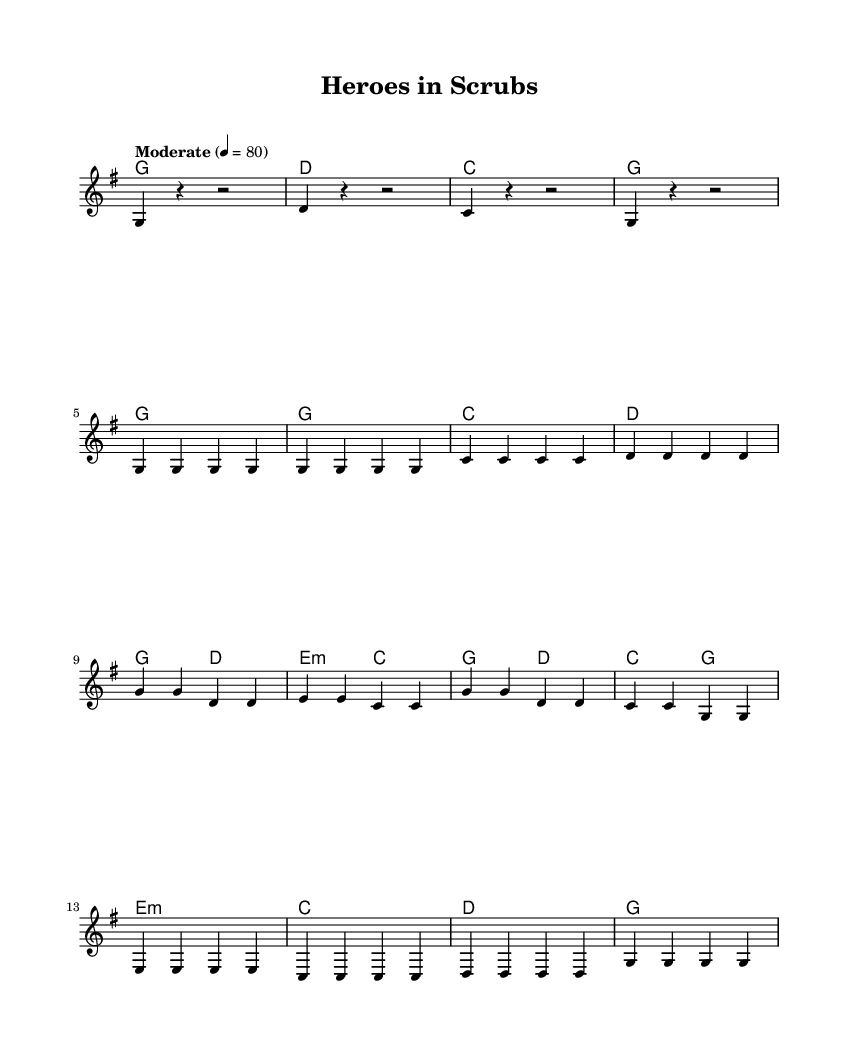What is the key signature of this music? The key signature is G major, which has one sharp (F#). This can be determined by looking at the key signature noted at the beginning of the score, which is indicated by the 'g' key specified.
Answer: G major What is the time signature of this music? The time signature is 4/4, which indicates four beats per measure and a quarter note gets one beat. This information is usually found at the beginning of the piece, immediately following the key signature.
Answer: 4/4 What is the tempo marking for this music? The tempo marking is "Moderate" with a speed of 80 beats per minute. This tells performers how fast or slow to play the piece, as shown in the tempo indication section of the score.
Answer: Moderate How many measures are in the melody section? There are 16 measures in the melody section, counting the melody notation from start to finish. Each line of the melody represents a series of measures. By subdividing it based on the measures and counting, we arrive at this total.
Answer: 16 What is the structure of the song? The structure of the song is Intro, Verse, Chorus, and Bridge, as indicated by labels breaking down each section in the code. This organization reflects the typical layout of many folk ballads where thematic elements are introduced and developed.
Answer: Intro, Verse, Chorus, Bridge Which section contains the line "Heroes in scrubs"? The line "Heroes in scrubs" is in the Chorus section, evident from the lyrics provided that correspond to that musical segment. The lyrics are separated into verses and choruses that directly match the melody lines.
Answer: Chorus How many unique chords are used in the harmonies? There are 5 unique chords used in the harmonies: G, D, C, E minor, and E. By examining the chord progression listed in the harmonies section, each distinct chord can be identified and counted.
Answer: 5 